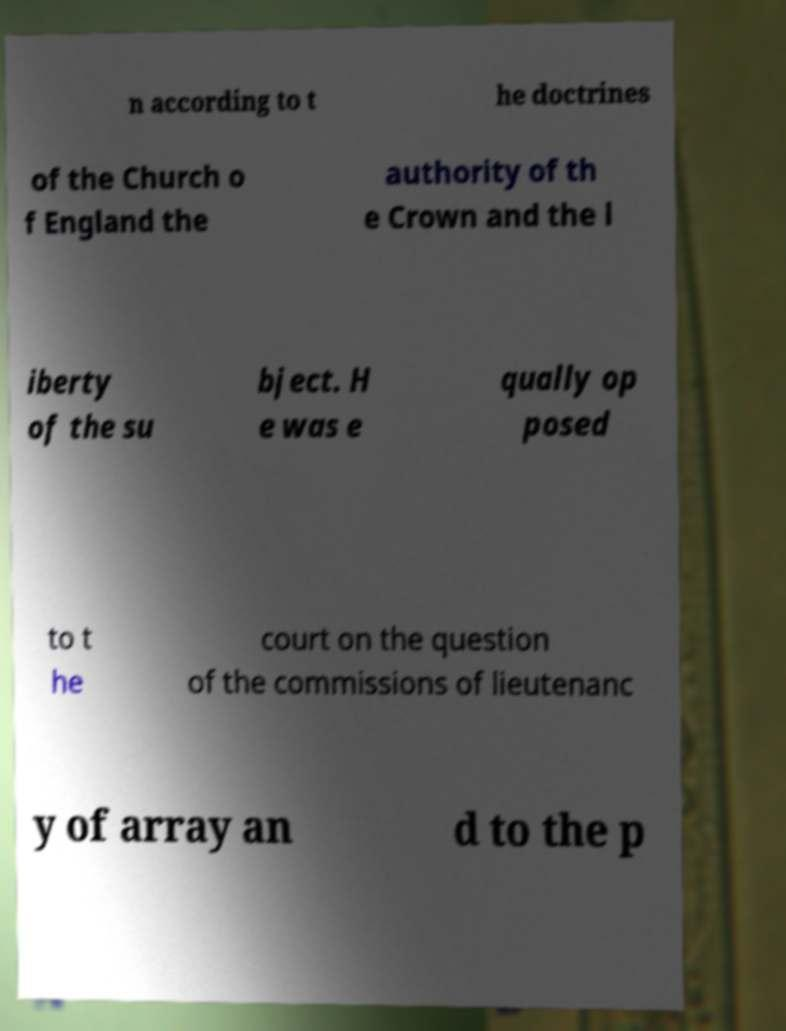Could you extract and type out the text from this image? n according to t he doctrines of the Church o f England the authority of th e Crown and the l iberty of the su bject. H e was e qually op posed to t he court on the question of the commissions of lieutenanc y of array an d to the p 